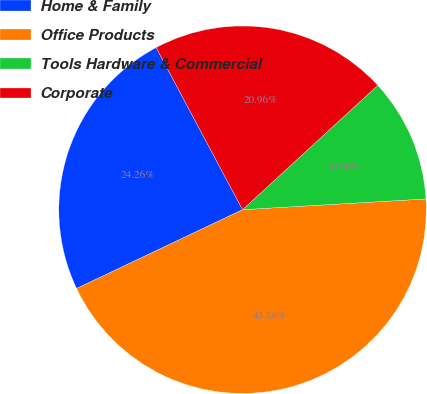Convert chart to OTSL. <chart><loc_0><loc_0><loc_500><loc_500><pie_chart><fcel>Home & Family<fcel>Office Products<fcel>Tools Hardware & Commercial<fcel>Corporate<nl><fcel>24.26%<fcel>43.88%<fcel>10.9%<fcel>20.96%<nl></chart> 